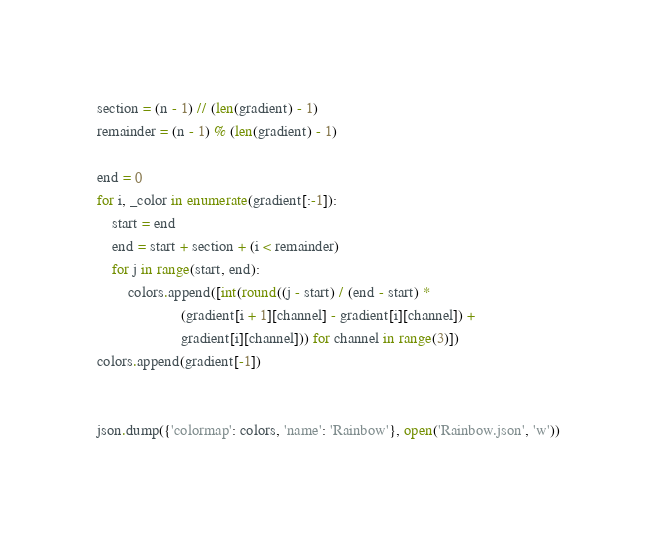Convert code to text. <code><loc_0><loc_0><loc_500><loc_500><_Python_>
section = (n - 1) // (len(gradient) - 1)
remainder = (n - 1) % (len(gradient) - 1)

end = 0
for i, _color in enumerate(gradient[:-1]):
    start = end
    end = start + section + (i < remainder)
    for j in range(start, end):
        colors.append([int(round((j - start) / (end - start) *
                      (gradient[i + 1][channel] - gradient[i][channel]) +
                      gradient[i][channel])) for channel in range(3)])
colors.append(gradient[-1])


json.dump({'colormap': colors, 'name': 'Rainbow'}, open('Rainbow.json', 'w'))
</code> 